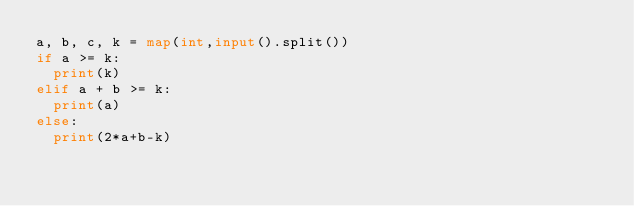Convert code to text. <code><loc_0><loc_0><loc_500><loc_500><_Python_>a, b, c, k = map(int,input().split())
if a >= k:
  print(k)
elif a + b >= k:
  print(a)
else:
  print(2*a+b-k)</code> 